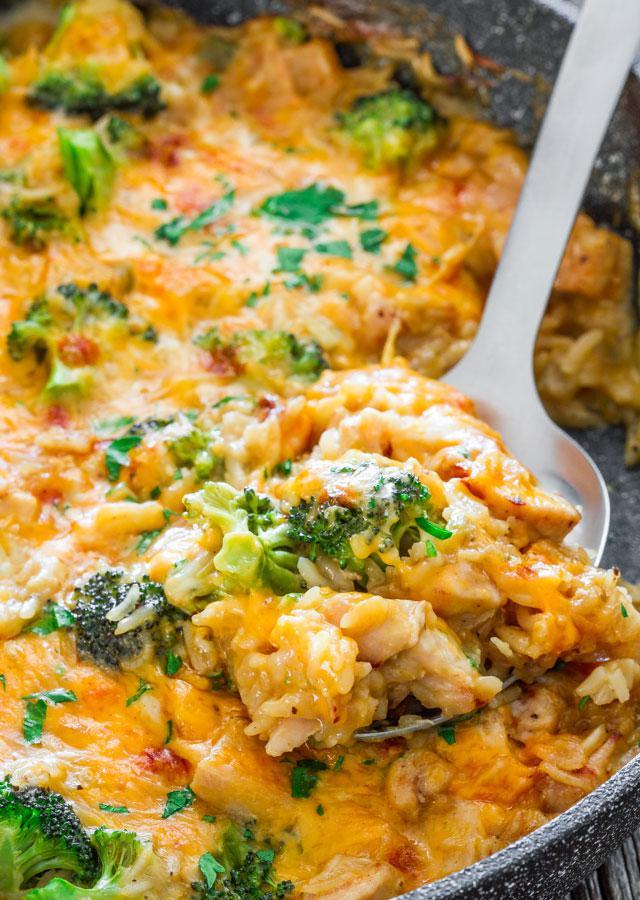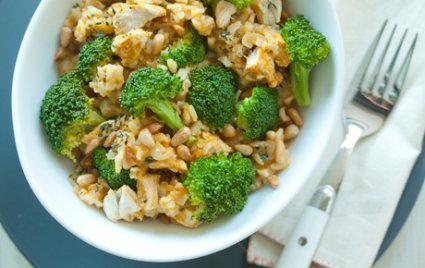The first image is the image on the left, the second image is the image on the right. Assess this claim about the two images: "There is a fork on one of the images.". Correct or not? Answer yes or no. Yes. 